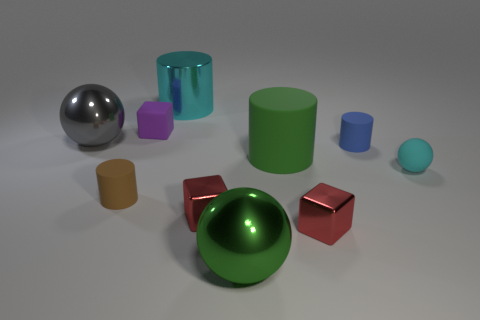Is the color of the big shiny cylinder the same as the rubber sphere?
Keep it short and to the point. Yes. Do the cyan cylinder and the brown object have the same material?
Give a very brief answer. No. What number of green matte objects are in front of the large shiny object in front of the tiny cyan rubber ball?
Make the answer very short. 0. Is there another thing that has the same shape as the tiny purple thing?
Your response must be concise. Yes. Is the shape of the tiny rubber object to the left of the purple thing the same as the large green object behind the big green ball?
Provide a short and direct response. Yes. What is the shape of the matte object that is in front of the small blue cylinder and behind the tiny cyan thing?
Ensure brevity in your answer.  Cylinder. Are there any gray objects that have the same size as the cyan cylinder?
Offer a terse response. Yes. Do the metal cylinder and the sphere that is right of the large green cylinder have the same color?
Make the answer very short. Yes. What material is the blue thing?
Ensure brevity in your answer.  Rubber. What color is the shiny sphere to the right of the purple matte cube?
Keep it short and to the point. Green. 